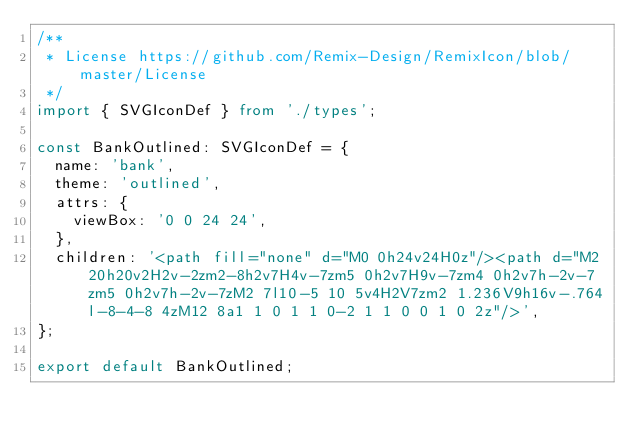<code> <loc_0><loc_0><loc_500><loc_500><_TypeScript_>/**
 * License https://github.com/Remix-Design/RemixIcon/blob/master/License
 */
import { SVGIconDef } from './types';

const BankOutlined: SVGIconDef = {
  name: 'bank',
  theme: 'outlined',
  attrs: {
    viewBox: '0 0 24 24',
  },
  children: '<path fill="none" d="M0 0h24v24H0z"/><path d="M2 20h20v2H2v-2zm2-8h2v7H4v-7zm5 0h2v7H9v-7zm4 0h2v7h-2v-7zm5 0h2v7h-2v-7zM2 7l10-5 10 5v4H2V7zm2 1.236V9h16v-.764l-8-4-8 4zM12 8a1 1 0 1 1 0-2 1 1 0 0 1 0 2z"/>',
};

export default BankOutlined;

</code> 